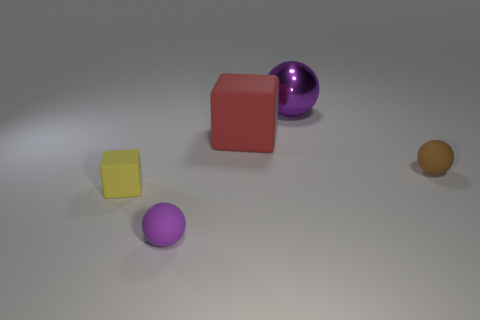Add 2 big brown blocks. How many objects exist? 7 Subtract all blocks. How many objects are left? 3 Subtract 0 purple cylinders. How many objects are left? 5 Subtract all big gray cylinders. Subtract all purple spheres. How many objects are left? 3 Add 1 large purple balls. How many large purple balls are left? 2 Add 1 rubber objects. How many rubber objects exist? 5 